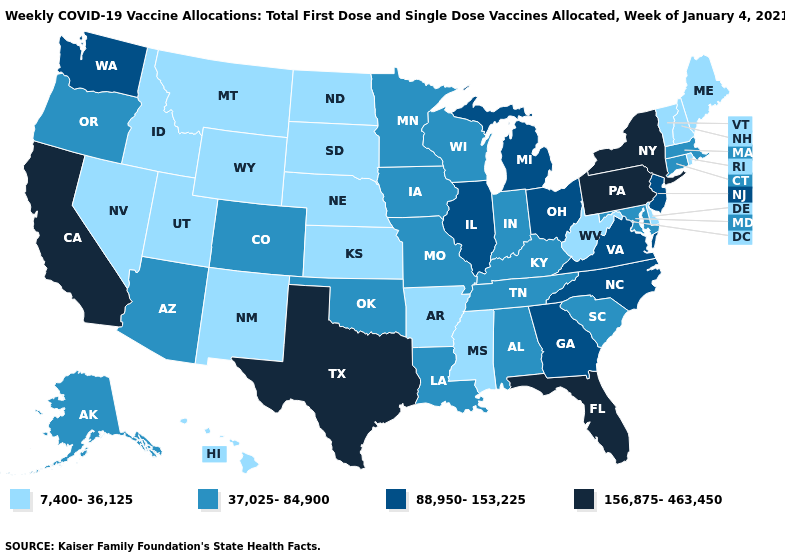Does the first symbol in the legend represent the smallest category?
Quick response, please. Yes. What is the value of Iowa?
Write a very short answer. 37,025-84,900. What is the highest value in the Northeast ?
Short answer required. 156,875-463,450. Does Virginia have a lower value than Texas?
Keep it brief. Yes. Does Nevada have the lowest value in the West?
Answer briefly. Yes. What is the value of Alabama?
Short answer required. 37,025-84,900. Does South Dakota have the lowest value in the MidWest?
Be succinct. Yes. What is the value of New York?
Keep it brief. 156,875-463,450. Among the states that border Delaware , which have the highest value?
Be succinct. Pennsylvania. Name the states that have a value in the range 7,400-36,125?
Short answer required. Arkansas, Delaware, Hawaii, Idaho, Kansas, Maine, Mississippi, Montana, Nebraska, Nevada, New Hampshire, New Mexico, North Dakota, Rhode Island, South Dakota, Utah, Vermont, West Virginia, Wyoming. What is the value of New Jersey?
Give a very brief answer. 88,950-153,225. Name the states that have a value in the range 37,025-84,900?
Be succinct. Alabama, Alaska, Arizona, Colorado, Connecticut, Indiana, Iowa, Kentucky, Louisiana, Maryland, Massachusetts, Minnesota, Missouri, Oklahoma, Oregon, South Carolina, Tennessee, Wisconsin. Name the states that have a value in the range 156,875-463,450?
Answer briefly. California, Florida, New York, Pennsylvania, Texas. Among the states that border Vermont , which have the lowest value?
Be succinct. New Hampshire. How many symbols are there in the legend?
Quick response, please. 4. 